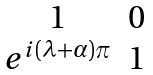<formula> <loc_0><loc_0><loc_500><loc_500>\begin{matrix} 1 & 0 \\ e ^ { i ( \lambda + \alpha ) \pi } & 1 \\ \end{matrix}</formula> 